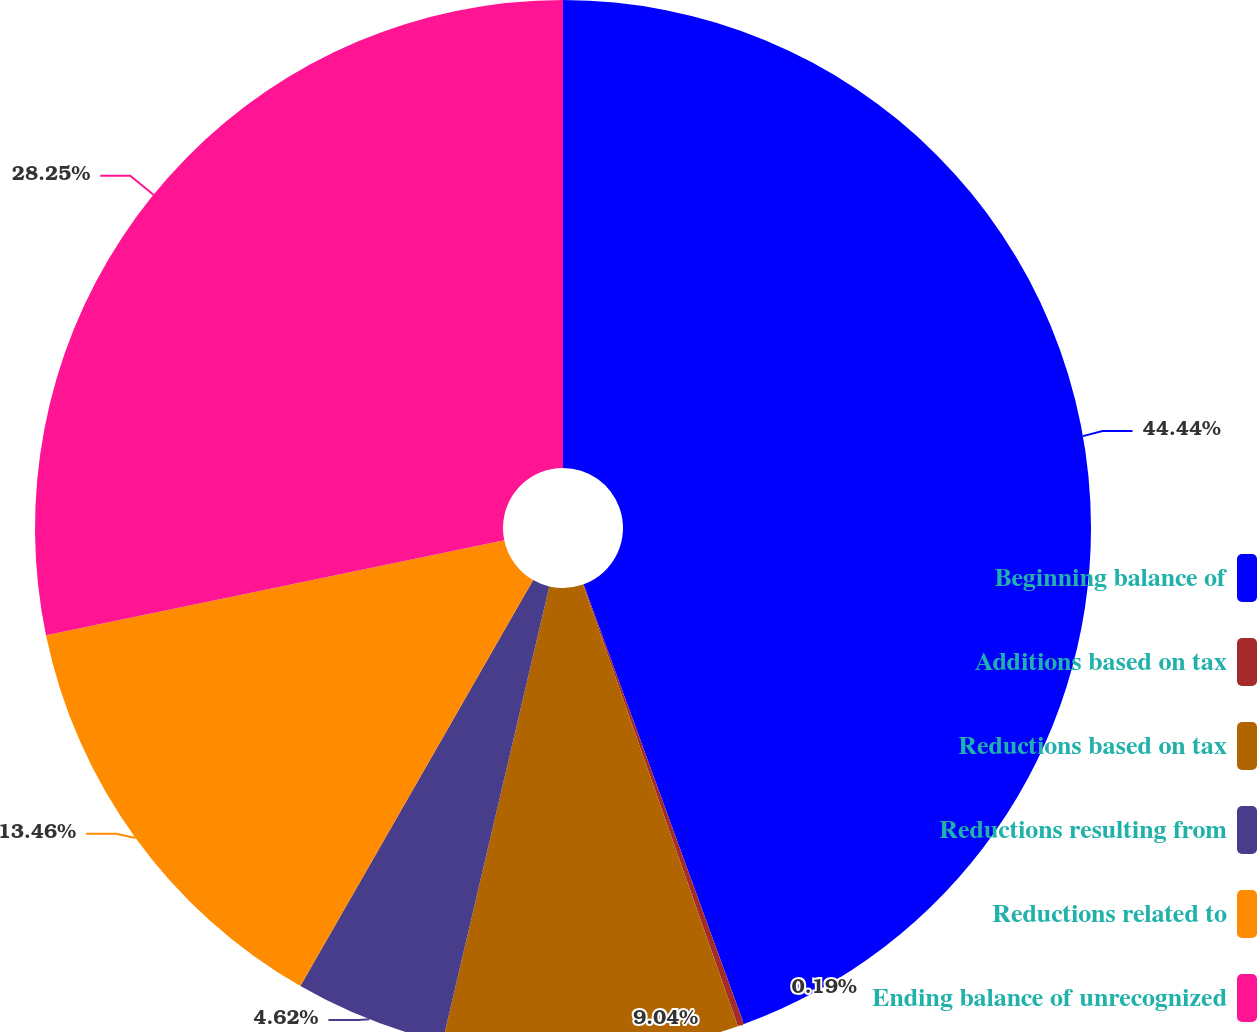Convert chart to OTSL. <chart><loc_0><loc_0><loc_500><loc_500><pie_chart><fcel>Beginning balance of<fcel>Additions based on tax<fcel>Reductions based on tax<fcel>Reductions resulting from<fcel>Reductions related to<fcel>Ending balance of unrecognized<nl><fcel>44.43%<fcel>0.19%<fcel>9.04%<fcel>4.62%<fcel>13.46%<fcel>28.25%<nl></chart> 